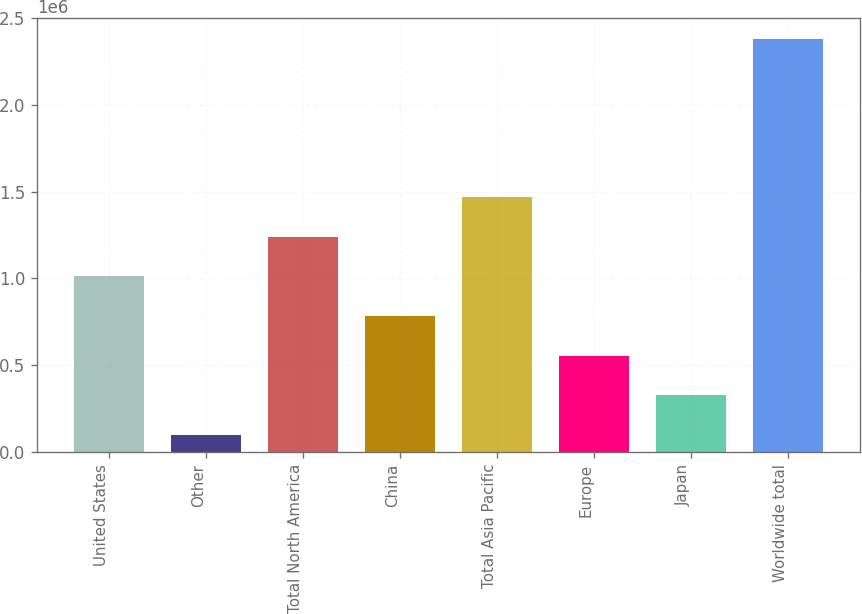Convert chart. <chart><loc_0><loc_0><loc_500><loc_500><bar_chart><fcel>United States<fcel>Other<fcel>Total North America<fcel>China<fcel>Total Asia Pacific<fcel>Europe<fcel>Japan<fcel>Worldwide total<nl><fcel>1.01146e+06<fcel>97416<fcel>1.23997e+06<fcel>782950<fcel>1.46848e+06<fcel>554439<fcel>325928<fcel>2.38253e+06<nl></chart> 